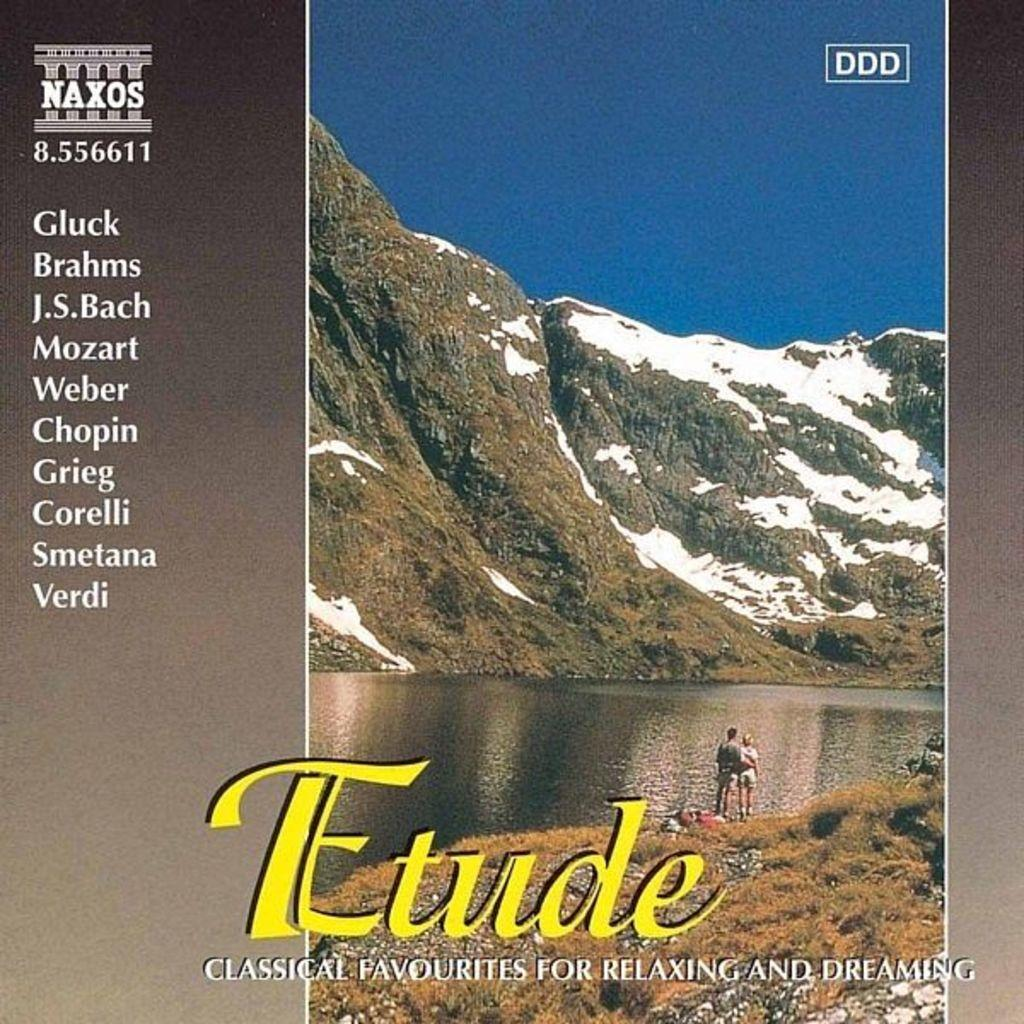<image>
Render a clear and concise summary of the photo. A cd called Etude that contains classical favorites for relaxing and dreaming. 